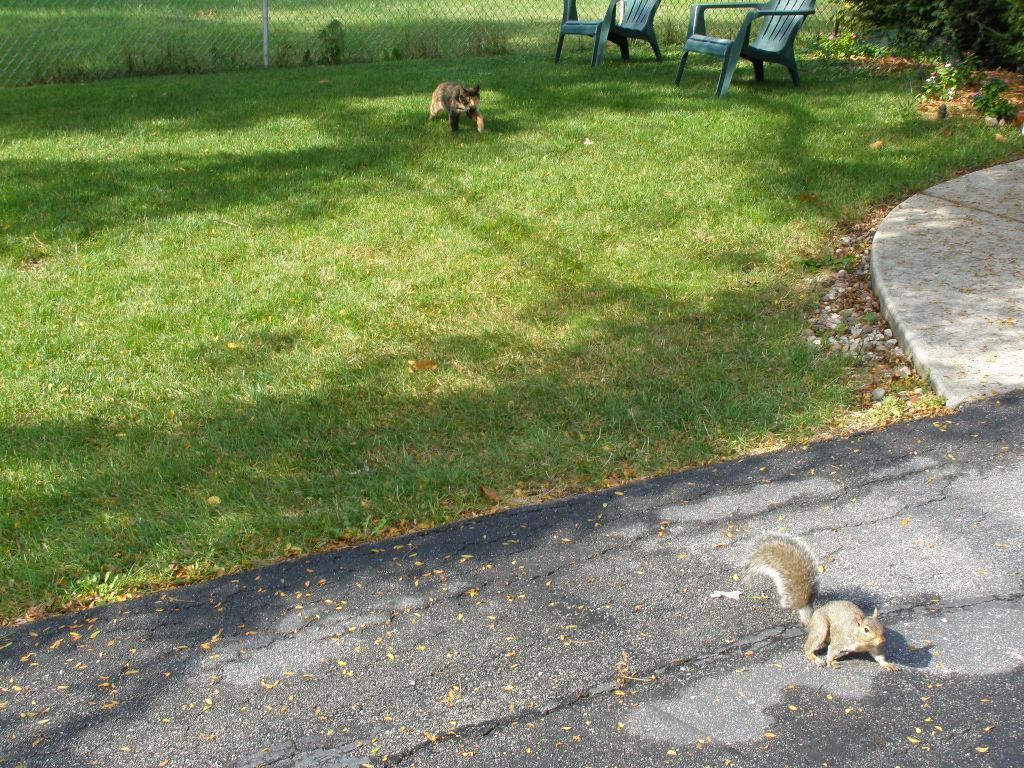Please provide a concise description of this image. a squirrel is present on the road. behind that there are grass and 2 chairs. in the center is a animal. behind that there is a fencing 